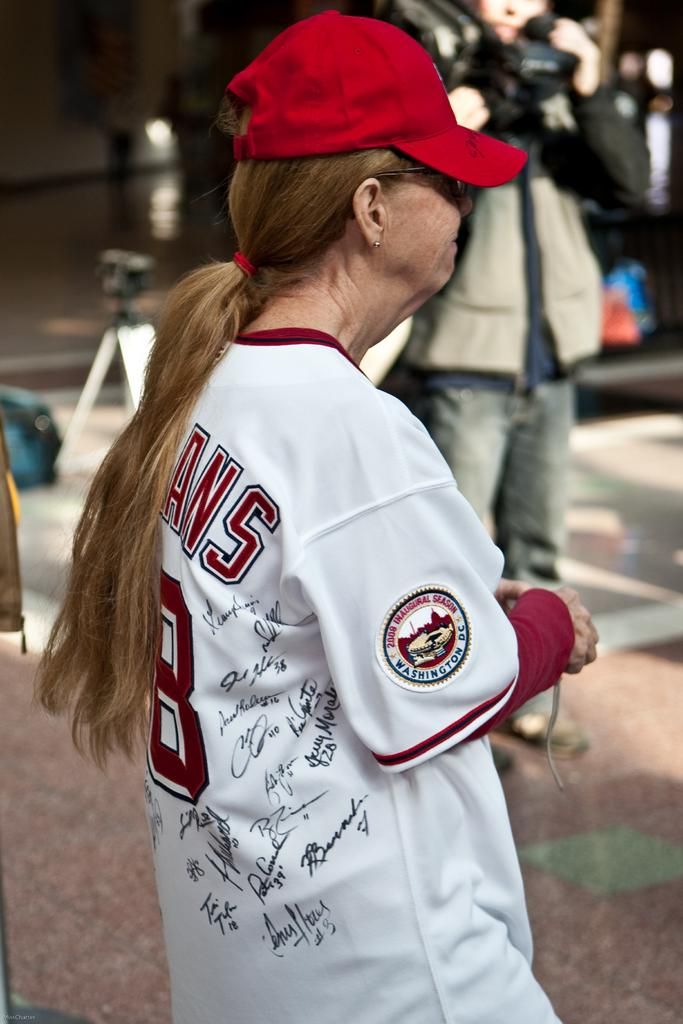<image>
Summarize the visual content of the image. A woman wears a jersey with the logo 2008 Inaugural Season sewn on the side 